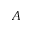Convert formula to latex. <formula><loc_0><loc_0><loc_500><loc_500>A</formula> 